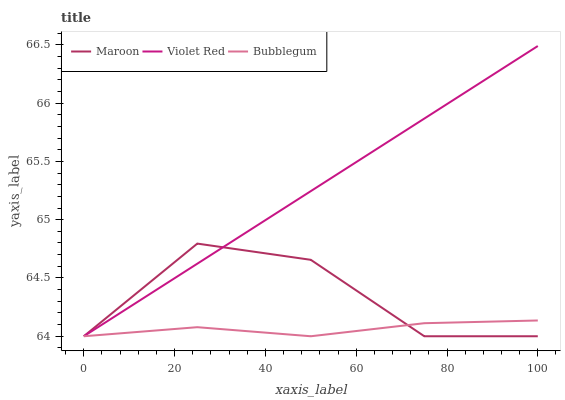Does Bubblegum have the minimum area under the curve?
Answer yes or no. Yes. Does Violet Red have the maximum area under the curve?
Answer yes or no. Yes. Does Maroon have the minimum area under the curve?
Answer yes or no. No. Does Maroon have the maximum area under the curve?
Answer yes or no. No. Is Violet Red the smoothest?
Answer yes or no. Yes. Is Maroon the roughest?
Answer yes or no. Yes. Is Bubblegum the smoothest?
Answer yes or no. No. Is Bubblegum the roughest?
Answer yes or no. No. Does Violet Red have the lowest value?
Answer yes or no. Yes. Does Violet Red have the highest value?
Answer yes or no. Yes. Does Maroon have the highest value?
Answer yes or no. No. Does Bubblegum intersect Violet Red?
Answer yes or no. Yes. Is Bubblegum less than Violet Red?
Answer yes or no. No. Is Bubblegum greater than Violet Red?
Answer yes or no. No. 